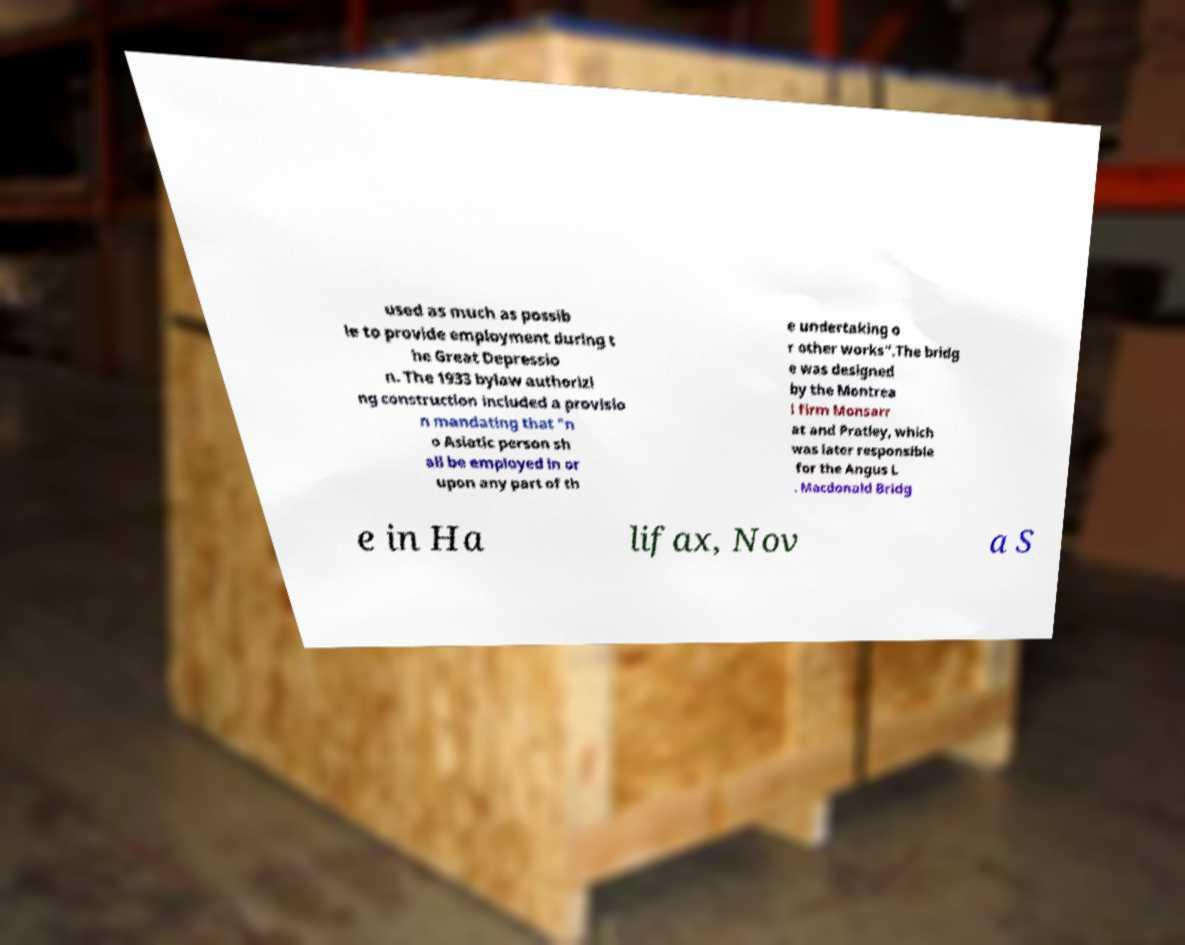I need the written content from this picture converted into text. Can you do that? used as much as possib le to provide employment during t he Great Depressio n. The 1933 bylaw authorizi ng construction included a provisio n mandating that "n o Asiatic person sh all be employed in or upon any part of th e undertaking o r other works".The bridg e was designed by the Montrea l firm Monsarr at and Pratley, which was later responsible for the Angus L . Macdonald Bridg e in Ha lifax, Nov a S 